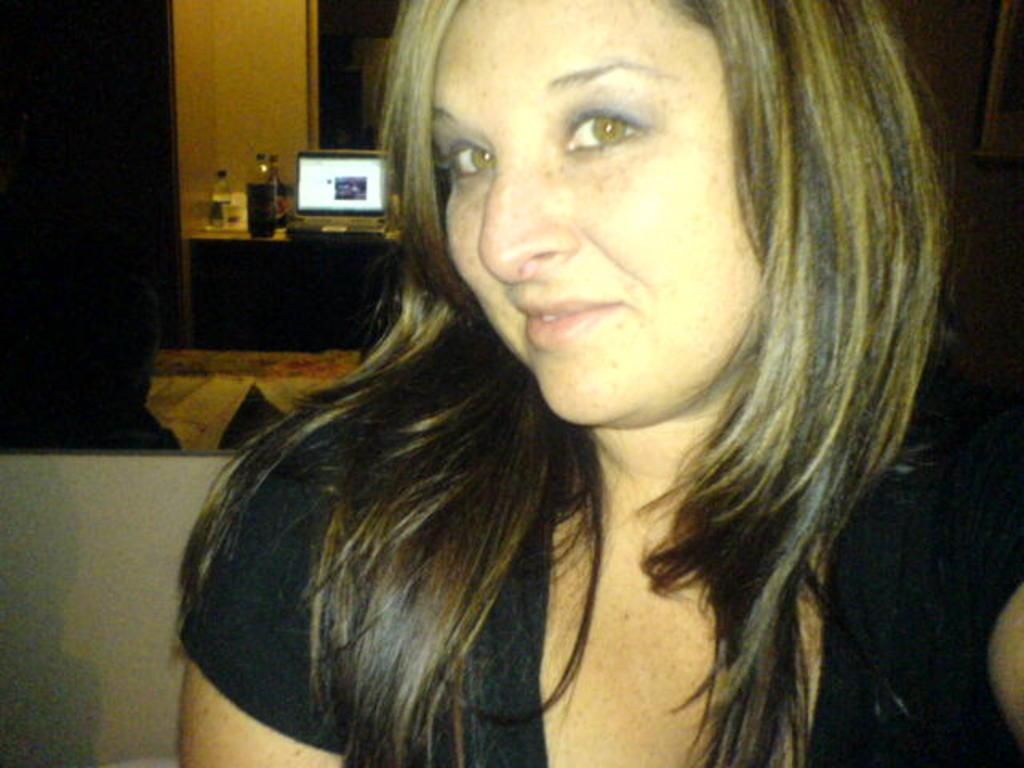Who is the main subject in the image? There is a woman in the image. Where is the woman located in the image? The woman is in the middle of the image. What can be seen in the background of the image? There is a table in the background of the image. What items are on the table? There are bottles and a laptop on the table. What type of glue is the woman using in the image? There is no glue present in the image, and the woman is not using any glue. What kind of voyage is the woman embarking on in the image? There is no voyage depicted in the image, and the woman is not embarking on any journey. 